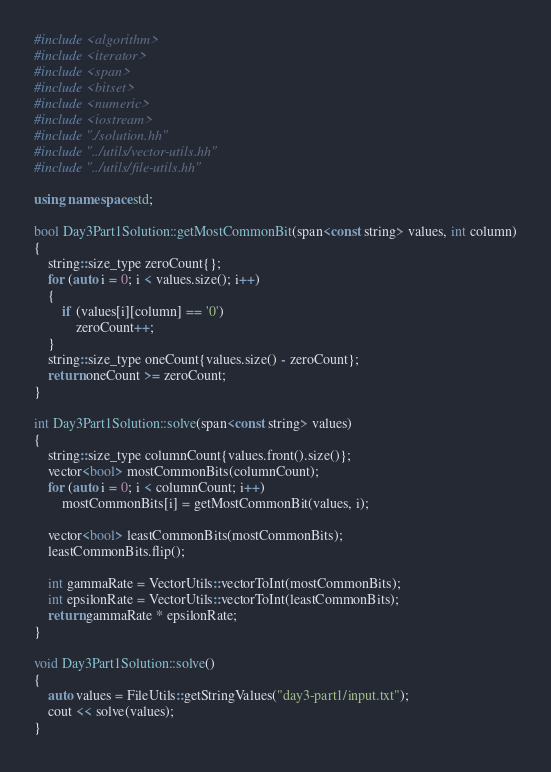Convert code to text. <code><loc_0><loc_0><loc_500><loc_500><_C++_>#include <algorithm>
#include <iterator>
#include <span>
#include <bitset>
#include <numeric>
#include <iostream>
#include "./solution.hh"
#include "../utils/vector-utils.hh"
#include "../utils/file-utils.hh"

using namespace std;

bool Day3Part1Solution::getMostCommonBit(span<const string> values, int column)
{
    string::size_type zeroCount{};
    for (auto i = 0; i < values.size(); i++)
    {
        if (values[i][column] == '0')
            zeroCount++;
    }
    string::size_type oneCount{values.size() - zeroCount};
    return oneCount >= zeroCount;
}

int Day3Part1Solution::solve(span<const string> values)
{
    string::size_type columnCount{values.front().size()};
    vector<bool> mostCommonBits(columnCount);
    for (auto i = 0; i < columnCount; i++)
        mostCommonBits[i] = getMostCommonBit(values, i);

    vector<bool> leastCommonBits(mostCommonBits);
    leastCommonBits.flip();

    int gammaRate = VectorUtils::vectorToInt(mostCommonBits);
    int epsilonRate = VectorUtils::vectorToInt(leastCommonBits);
    return gammaRate * epsilonRate;
}

void Day3Part1Solution::solve()
{
    auto values = FileUtils::getStringValues("day3-part1/input.txt");
    cout << solve(values);
}
</code> 